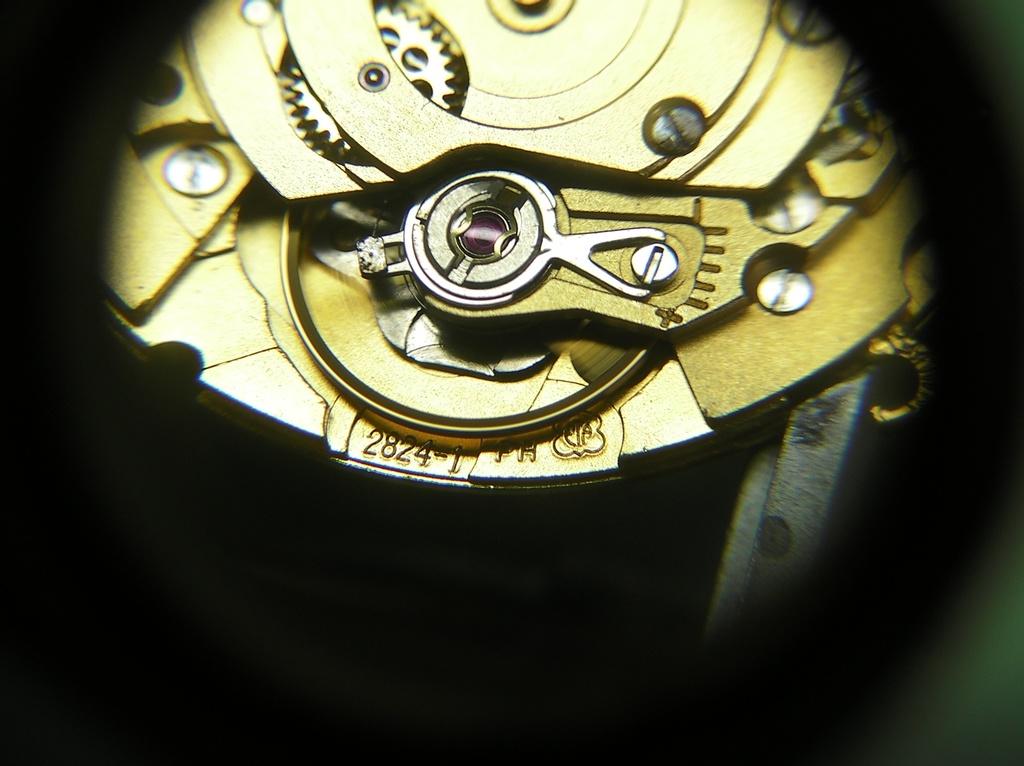What is the serial number of this watch?
Offer a very short reply. 2824-1. 